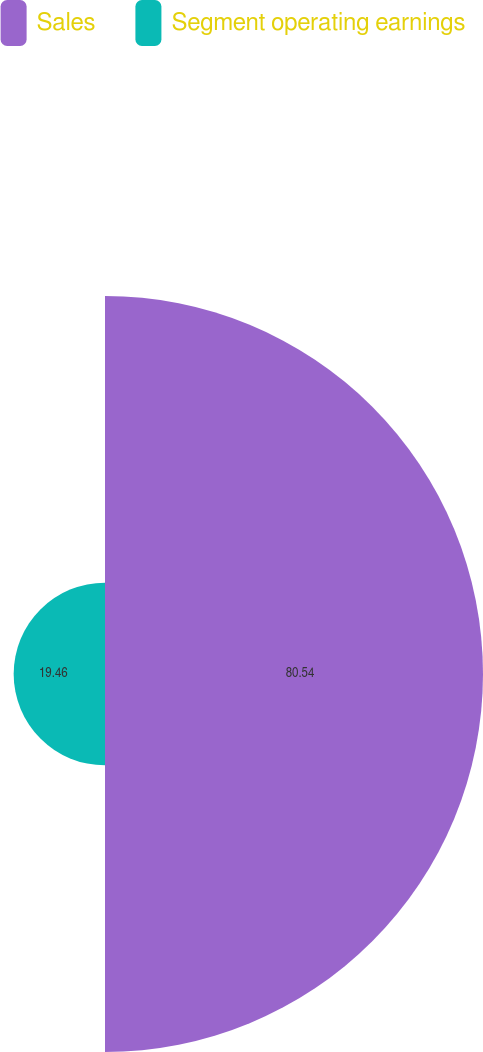<chart> <loc_0><loc_0><loc_500><loc_500><pie_chart><fcel>Sales<fcel>Segment operating earnings<nl><fcel>80.54%<fcel>19.46%<nl></chart> 